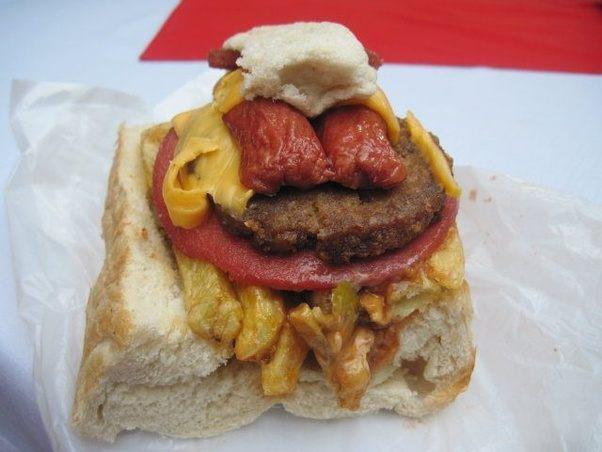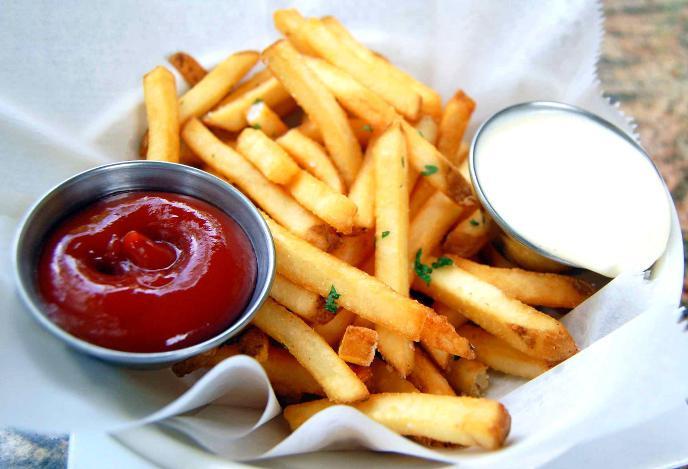The first image is the image on the left, the second image is the image on the right. For the images shown, is this caption "The left image shows a sandwich with contents that include french fries, cheese and a round slice of meat stacked on bread." true? Answer yes or no. Yes. The first image is the image on the left, the second image is the image on the right. For the images displayed, is the sentence "One of the items contains lettuce." factually correct? Answer yes or no. No. 